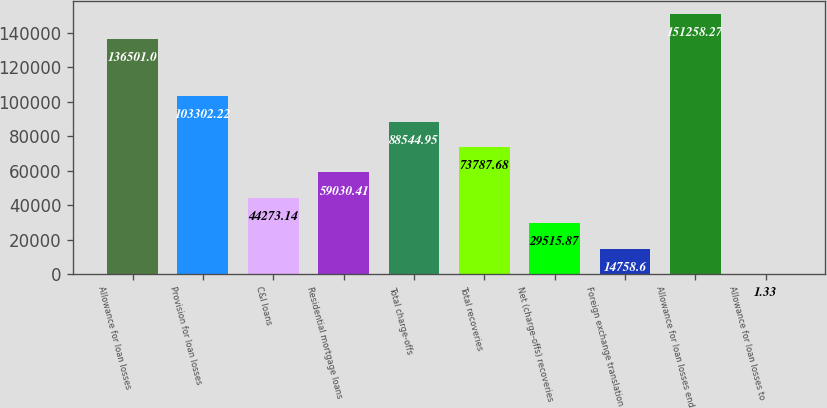<chart> <loc_0><loc_0><loc_500><loc_500><bar_chart><fcel>Allowance for loan losses<fcel>Provision for loan losses<fcel>C&I loans<fcel>Residential mortgage loans<fcel>Total charge-offs<fcel>Total recoveries<fcel>Net (charge-offs) recoveries<fcel>Foreign exchange translation<fcel>Allowance for loan losses end<fcel>Allowance for loan losses to<nl><fcel>136501<fcel>103302<fcel>44273.1<fcel>59030.4<fcel>88544.9<fcel>73787.7<fcel>29515.9<fcel>14758.6<fcel>151258<fcel>1.33<nl></chart> 